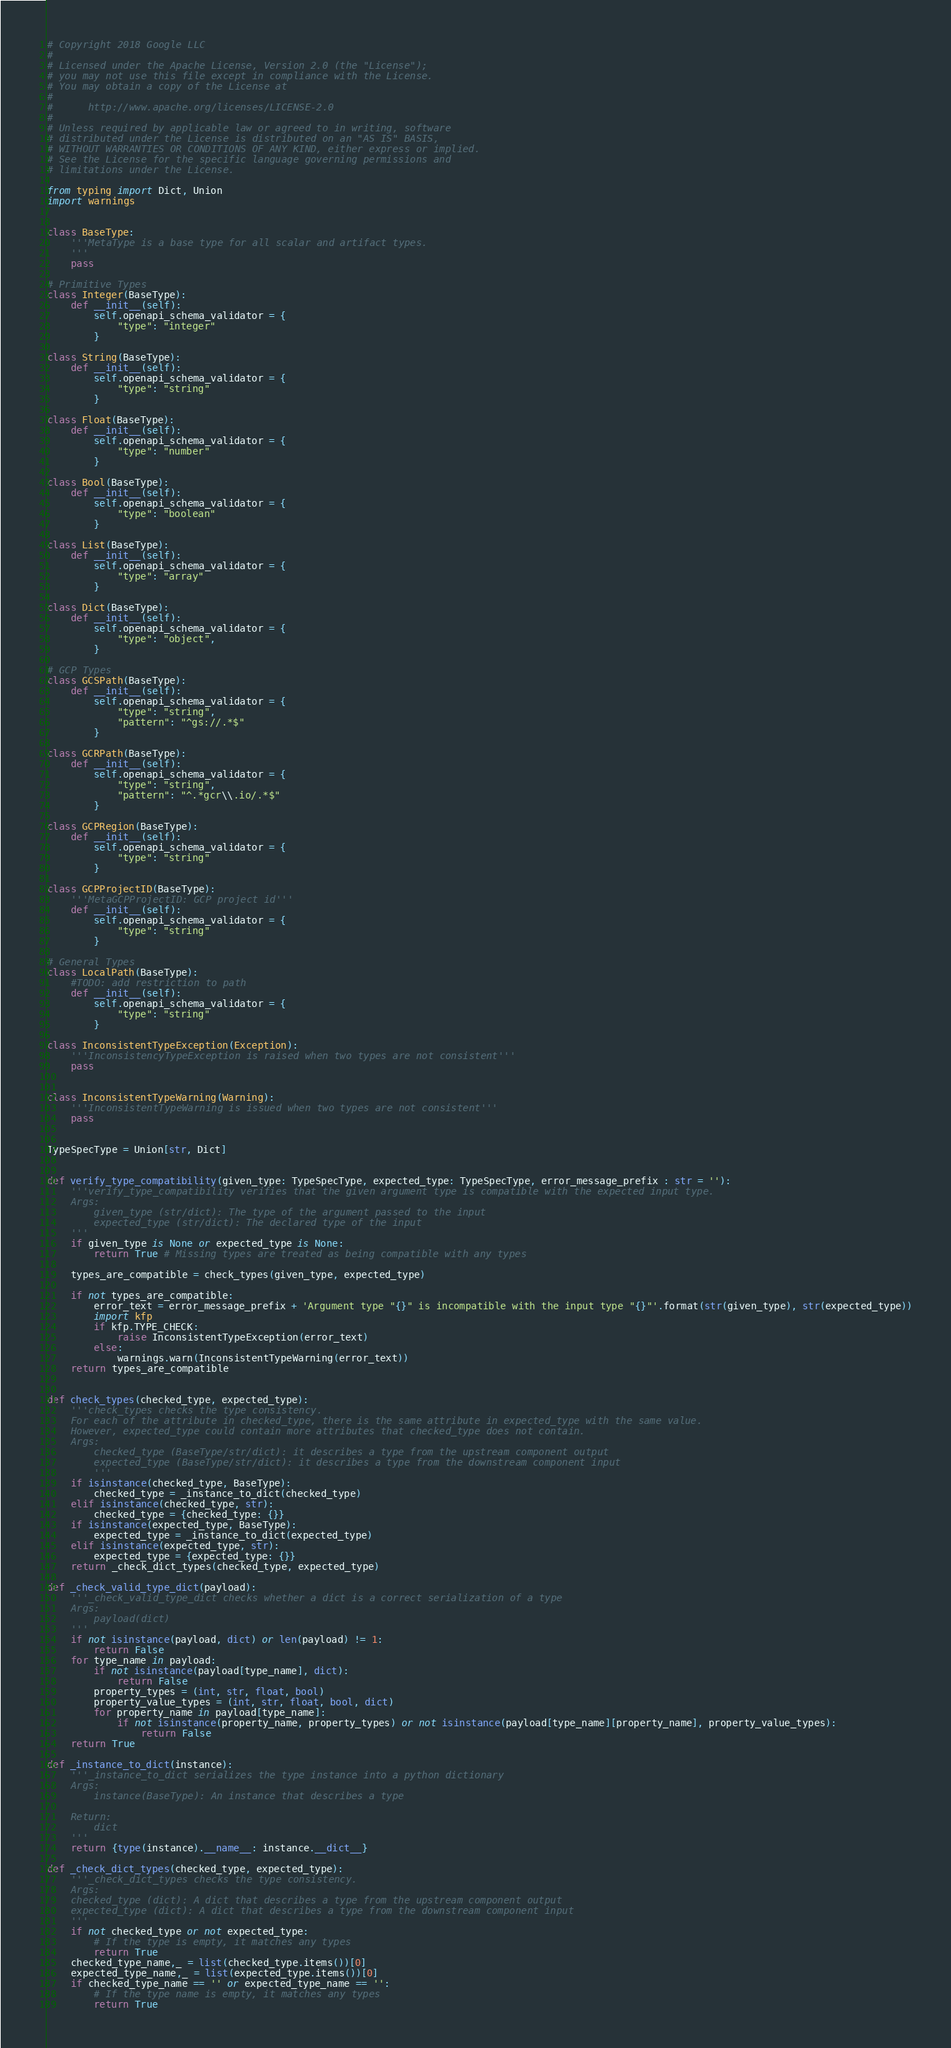Convert code to text. <code><loc_0><loc_0><loc_500><loc_500><_Python_># Copyright 2018 Google LLC
#
# Licensed under the Apache License, Version 2.0 (the "License");
# you may not use this file except in compliance with the License.
# You may obtain a copy of the License at
#
#      http://www.apache.org/licenses/LICENSE-2.0
#
# Unless required by applicable law or agreed to in writing, software
# distributed under the License is distributed on an "AS IS" BASIS,
# WITHOUT WARRANTIES OR CONDITIONS OF ANY KIND, either express or implied.
# See the License for the specific language governing permissions and
# limitations under the License.

from typing import Dict, Union
import warnings


class BaseType:
	'''MetaType is a base type for all scalar and artifact types.
	'''
	pass

# Primitive Types
class Integer(BaseType):
	def __init__(self):
		self.openapi_schema_validator = {
			"type": "integer"
		}

class String(BaseType):
	def __init__(self):
		self.openapi_schema_validator = {
			"type": "string"
		}

class Float(BaseType):
	def __init__(self):
		self.openapi_schema_validator = {
			"type": "number"
		}

class Bool(BaseType):
	def __init__(self):
		self.openapi_schema_validator = {
			"type": "boolean"
		}

class List(BaseType):
	def __init__(self):
		self.openapi_schema_validator = {
			"type": "array"
		}

class Dict(BaseType):
	def __init__(self):
		self.openapi_schema_validator = {
			"type": "object",
		}

# GCP Types
class GCSPath(BaseType):
	def __init__(self):
		self.openapi_schema_validator = {
			"type": "string",
			"pattern": "^gs://.*$"
		}

class GCRPath(BaseType):
	def __init__(self):
		self.openapi_schema_validator = {
			"type": "string",
			"pattern": "^.*gcr\\.io/.*$"
		}

class GCPRegion(BaseType):
	def __init__(self):
		self.openapi_schema_validator = {
			"type": "string"
		}

class GCPProjectID(BaseType):
	'''MetaGCPProjectID: GCP project id'''
	def __init__(self):
		self.openapi_schema_validator = {
			"type": "string"
		}

# General Types
class LocalPath(BaseType):
	#TODO: add restriction to path
	def __init__(self):
		self.openapi_schema_validator = {
			"type": "string"
		}

class InconsistentTypeException(Exception):
	'''InconsistencyTypeException is raised when two types are not consistent'''
	pass


class InconsistentTypeWarning(Warning):
	'''InconsistentTypeWarning is issued when two types are not consistent'''
	pass


TypeSpecType = Union[str, Dict]


def verify_type_compatibility(given_type: TypeSpecType, expected_type: TypeSpecType, error_message_prefix : str = ''):
	'''verify_type_compatibility verifies that the given argument type is compatible with the expected input type.
	Args:
		given_type (str/dict): The type of the argument passed to the input
		expected_type (str/dict): The declared type of the input
	'''
	if given_type is None or expected_type is None:
		return True # Missing types are treated as being compatible with any types

	types_are_compatible = check_types(given_type, expected_type)

	if not types_are_compatible:
		error_text = error_message_prefix + 'Argument type "{}" is incompatible with the input type "{}"'.format(str(given_type), str(expected_type))
		import kfp
		if kfp.TYPE_CHECK:
			raise InconsistentTypeException(error_text)
		else:
			warnings.warn(InconsistentTypeWarning(error_text))
	return types_are_compatible


def check_types(checked_type, expected_type):
	'''check_types checks the type consistency.
	For each of the attribute in checked_type, there is the same attribute in expected_type with the same value.
	However, expected_type could contain more attributes that checked_type does not contain.
	Args:
		checked_type (BaseType/str/dict): it describes a type from the upstream component output
		expected_type (BaseType/str/dict): it describes a type from the downstream component input
		'''
	if isinstance(checked_type, BaseType):
		checked_type = _instance_to_dict(checked_type)
	elif isinstance(checked_type, str):
		checked_type = {checked_type: {}}
	if isinstance(expected_type, BaseType):
		expected_type = _instance_to_dict(expected_type)
	elif isinstance(expected_type, str):
		expected_type = {expected_type: {}}
	return _check_dict_types(checked_type, expected_type)

def _check_valid_type_dict(payload):
	'''_check_valid_type_dict checks whether a dict is a correct serialization of a type
	Args:
		payload(dict)
	'''
	if not isinstance(payload, dict) or len(payload) != 1:
		return False
	for type_name in payload:
		if not isinstance(payload[type_name], dict):
			return False
		property_types = (int, str, float, bool)
		property_value_types = (int, str, float, bool, dict)
		for property_name in payload[type_name]:
			if not isinstance(property_name, property_types) or not isinstance(payload[type_name][property_name], property_value_types):
				return False
	return True

def _instance_to_dict(instance):
	'''_instance_to_dict serializes the type instance into a python dictionary
	Args:
		instance(BaseType): An instance that describes a type

	Return:
		dict
	'''
	return {type(instance).__name__: instance.__dict__}

def _check_dict_types(checked_type, expected_type):
	'''_check_dict_types checks the type consistency.
	Args:
  	checked_type (dict): A dict that describes a type from the upstream component output
  	expected_type (dict): A dict that describes a type from the downstream component input
	'''
	if not checked_type or not expected_type:
		# If the type is empty, it matches any types
		return True
	checked_type_name,_ = list(checked_type.items())[0]
	expected_type_name,_ = list(expected_type.items())[0]
	if checked_type_name == '' or expected_type_name == '':
		# If the type name is empty, it matches any types
		return True</code> 